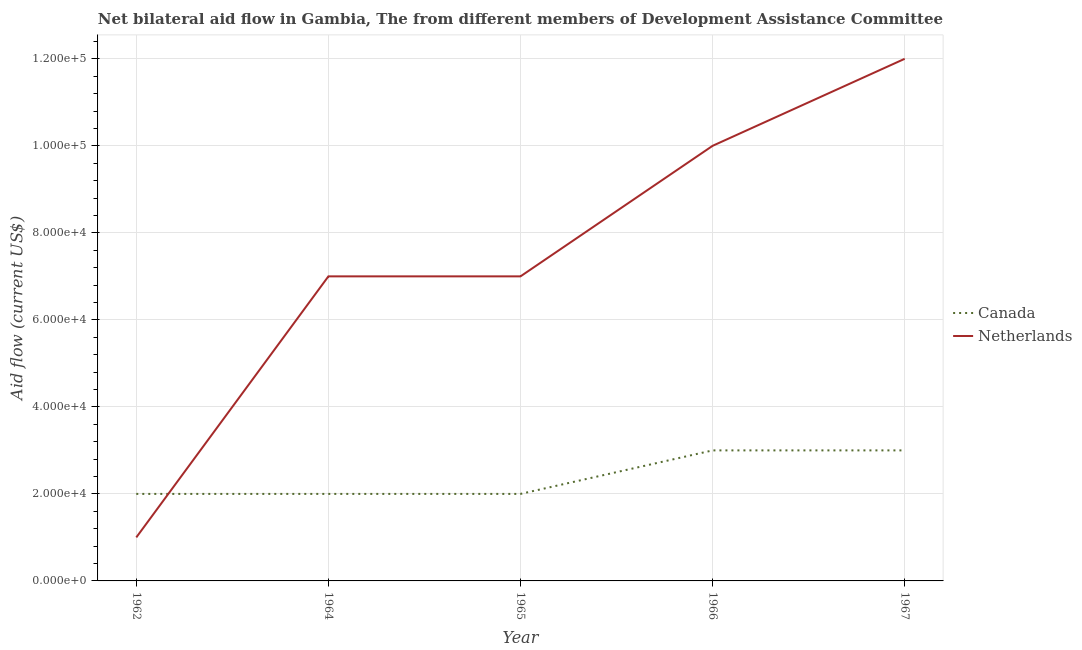How many different coloured lines are there?
Your answer should be very brief. 2. Does the line corresponding to amount of aid given by canada intersect with the line corresponding to amount of aid given by netherlands?
Make the answer very short. Yes. Is the number of lines equal to the number of legend labels?
Give a very brief answer. Yes. What is the amount of aid given by netherlands in 1964?
Offer a very short reply. 7.00e+04. Across all years, what is the maximum amount of aid given by canada?
Offer a very short reply. 3.00e+04. Across all years, what is the minimum amount of aid given by netherlands?
Your answer should be compact. 10000. In which year was the amount of aid given by canada maximum?
Your answer should be very brief. 1966. In which year was the amount of aid given by canada minimum?
Keep it short and to the point. 1962. What is the total amount of aid given by netherlands in the graph?
Offer a terse response. 3.70e+05. What is the difference between the amount of aid given by netherlands in 1964 and that in 1967?
Ensure brevity in your answer.  -5.00e+04. What is the difference between the amount of aid given by canada in 1962 and the amount of aid given by netherlands in 1965?
Provide a short and direct response. -5.00e+04. What is the average amount of aid given by canada per year?
Keep it short and to the point. 2.40e+04. In the year 1964, what is the difference between the amount of aid given by canada and amount of aid given by netherlands?
Offer a very short reply. -5.00e+04. What is the ratio of the amount of aid given by netherlands in 1964 to that in 1966?
Ensure brevity in your answer.  0.7. Is the difference between the amount of aid given by netherlands in 1964 and 1967 greater than the difference between the amount of aid given by canada in 1964 and 1967?
Give a very brief answer. No. What is the difference between the highest and the lowest amount of aid given by netherlands?
Provide a succinct answer. 1.10e+05. Is the sum of the amount of aid given by canada in 1966 and 1967 greater than the maximum amount of aid given by netherlands across all years?
Provide a succinct answer. No. Is the amount of aid given by netherlands strictly less than the amount of aid given by canada over the years?
Ensure brevity in your answer.  No. How many lines are there?
Your answer should be compact. 2. How many years are there in the graph?
Make the answer very short. 5. Does the graph contain any zero values?
Your answer should be very brief. No. Does the graph contain grids?
Provide a succinct answer. Yes. How many legend labels are there?
Your response must be concise. 2. What is the title of the graph?
Your response must be concise. Net bilateral aid flow in Gambia, The from different members of Development Assistance Committee. What is the label or title of the Y-axis?
Keep it short and to the point. Aid flow (current US$). What is the Aid flow (current US$) in Netherlands in 1962?
Offer a very short reply. 10000. What is the Aid flow (current US$) of Canada in 1964?
Offer a terse response. 2.00e+04. What is the Aid flow (current US$) of Canada in 1965?
Provide a short and direct response. 2.00e+04. What is the Aid flow (current US$) in Canada in 1966?
Make the answer very short. 3.00e+04. What is the Aid flow (current US$) of Netherlands in 1966?
Make the answer very short. 1.00e+05. What is the Aid flow (current US$) in Canada in 1967?
Your answer should be compact. 3.00e+04. Across all years, what is the maximum Aid flow (current US$) of Netherlands?
Give a very brief answer. 1.20e+05. Across all years, what is the minimum Aid flow (current US$) of Canada?
Offer a terse response. 2.00e+04. Across all years, what is the minimum Aid flow (current US$) in Netherlands?
Offer a terse response. 10000. What is the total Aid flow (current US$) in Canada in the graph?
Offer a very short reply. 1.20e+05. What is the difference between the Aid flow (current US$) in Canada in 1962 and that in 1965?
Make the answer very short. 0. What is the difference between the Aid flow (current US$) in Canada in 1962 and that in 1966?
Keep it short and to the point. -10000. What is the difference between the Aid flow (current US$) of Netherlands in 1962 and that in 1966?
Keep it short and to the point. -9.00e+04. What is the difference between the Aid flow (current US$) of Canada in 1964 and that in 1965?
Ensure brevity in your answer.  0. What is the difference between the Aid flow (current US$) in Netherlands in 1964 and that in 1965?
Give a very brief answer. 0. What is the difference between the Aid flow (current US$) in Canada in 1964 and that in 1966?
Your response must be concise. -10000. What is the difference between the Aid flow (current US$) of Canada in 1964 and that in 1967?
Provide a succinct answer. -10000. What is the difference between the Aid flow (current US$) of Netherlands in 1964 and that in 1967?
Provide a succinct answer. -5.00e+04. What is the difference between the Aid flow (current US$) in Canada in 1965 and that in 1966?
Give a very brief answer. -10000. What is the difference between the Aid flow (current US$) in Netherlands in 1965 and that in 1967?
Your answer should be very brief. -5.00e+04. What is the difference between the Aid flow (current US$) in Canada in 1962 and the Aid flow (current US$) in Netherlands in 1964?
Your answer should be compact. -5.00e+04. What is the difference between the Aid flow (current US$) in Canada in 1962 and the Aid flow (current US$) in Netherlands in 1966?
Offer a very short reply. -8.00e+04. What is the difference between the Aid flow (current US$) in Canada in 1962 and the Aid flow (current US$) in Netherlands in 1967?
Keep it short and to the point. -1.00e+05. What is the difference between the Aid flow (current US$) of Canada in 1964 and the Aid flow (current US$) of Netherlands in 1965?
Offer a very short reply. -5.00e+04. What is the difference between the Aid flow (current US$) of Canada in 1964 and the Aid flow (current US$) of Netherlands in 1966?
Provide a short and direct response. -8.00e+04. What is the difference between the Aid flow (current US$) in Canada in 1965 and the Aid flow (current US$) in Netherlands in 1966?
Your answer should be compact. -8.00e+04. What is the difference between the Aid flow (current US$) of Canada in 1966 and the Aid flow (current US$) of Netherlands in 1967?
Your answer should be compact. -9.00e+04. What is the average Aid flow (current US$) in Canada per year?
Ensure brevity in your answer.  2.40e+04. What is the average Aid flow (current US$) in Netherlands per year?
Make the answer very short. 7.40e+04. In the year 1962, what is the difference between the Aid flow (current US$) in Canada and Aid flow (current US$) in Netherlands?
Offer a very short reply. 10000. In the year 1965, what is the difference between the Aid flow (current US$) in Canada and Aid flow (current US$) in Netherlands?
Make the answer very short. -5.00e+04. In the year 1966, what is the difference between the Aid flow (current US$) in Canada and Aid flow (current US$) in Netherlands?
Your response must be concise. -7.00e+04. What is the ratio of the Aid flow (current US$) of Canada in 1962 to that in 1964?
Make the answer very short. 1. What is the ratio of the Aid flow (current US$) in Netherlands in 1962 to that in 1964?
Keep it short and to the point. 0.14. What is the ratio of the Aid flow (current US$) in Netherlands in 1962 to that in 1965?
Give a very brief answer. 0.14. What is the ratio of the Aid flow (current US$) of Canada in 1962 to that in 1966?
Your answer should be compact. 0.67. What is the ratio of the Aid flow (current US$) of Netherlands in 1962 to that in 1966?
Your answer should be compact. 0.1. What is the ratio of the Aid flow (current US$) in Netherlands in 1962 to that in 1967?
Make the answer very short. 0.08. What is the ratio of the Aid flow (current US$) in Netherlands in 1964 to that in 1965?
Your answer should be compact. 1. What is the ratio of the Aid flow (current US$) of Canada in 1964 to that in 1966?
Keep it short and to the point. 0.67. What is the ratio of the Aid flow (current US$) of Netherlands in 1964 to that in 1966?
Offer a terse response. 0.7. What is the ratio of the Aid flow (current US$) of Netherlands in 1964 to that in 1967?
Keep it short and to the point. 0.58. What is the ratio of the Aid flow (current US$) of Canada in 1965 to that in 1967?
Offer a very short reply. 0.67. What is the ratio of the Aid flow (current US$) of Netherlands in 1965 to that in 1967?
Your answer should be compact. 0.58. What is the ratio of the Aid flow (current US$) of Canada in 1966 to that in 1967?
Your response must be concise. 1. What is the ratio of the Aid flow (current US$) in Netherlands in 1966 to that in 1967?
Provide a short and direct response. 0.83. What is the difference between the highest and the second highest Aid flow (current US$) of Canada?
Provide a short and direct response. 0. What is the difference between the highest and the second highest Aid flow (current US$) of Netherlands?
Offer a terse response. 2.00e+04. What is the difference between the highest and the lowest Aid flow (current US$) of Canada?
Provide a succinct answer. 10000. What is the difference between the highest and the lowest Aid flow (current US$) in Netherlands?
Make the answer very short. 1.10e+05. 